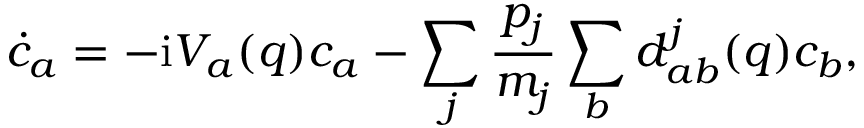Convert formula to latex. <formula><loc_0><loc_0><loc_500><loc_500>\dot { c } _ { a } = - i V _ { a } ( q ) c _ { a } - \sum _ { j } \frac { p _ { j } } { m _ { j } } \sum _ { b } d _ { a b } ^ { j } ( q ) c _ { b } ,</formula> 